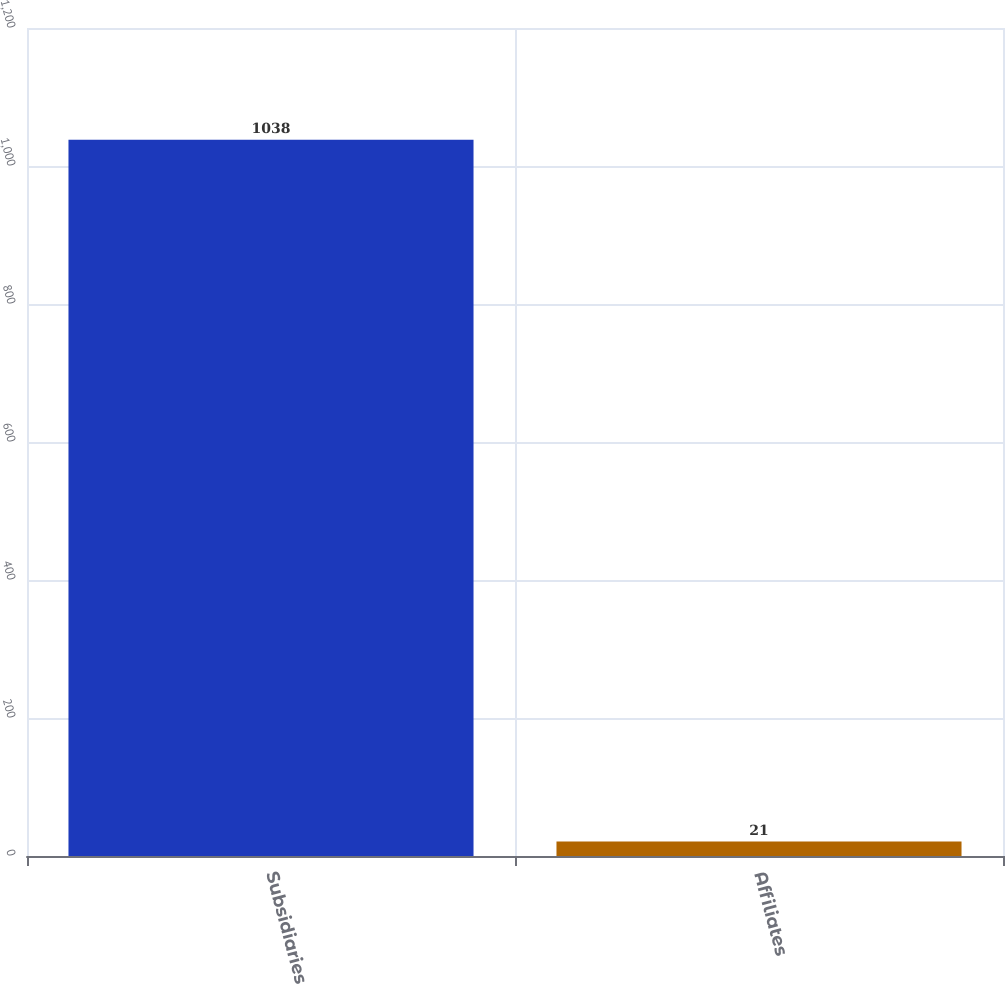Convert chart to OTSL. <chart><loc_0><loc_0><loc_500><loc_500><bar_chart><fcel>Subsidiaries<fcel>Affiliates<nl><fcel>1038<fcel>21<nl></chart> 